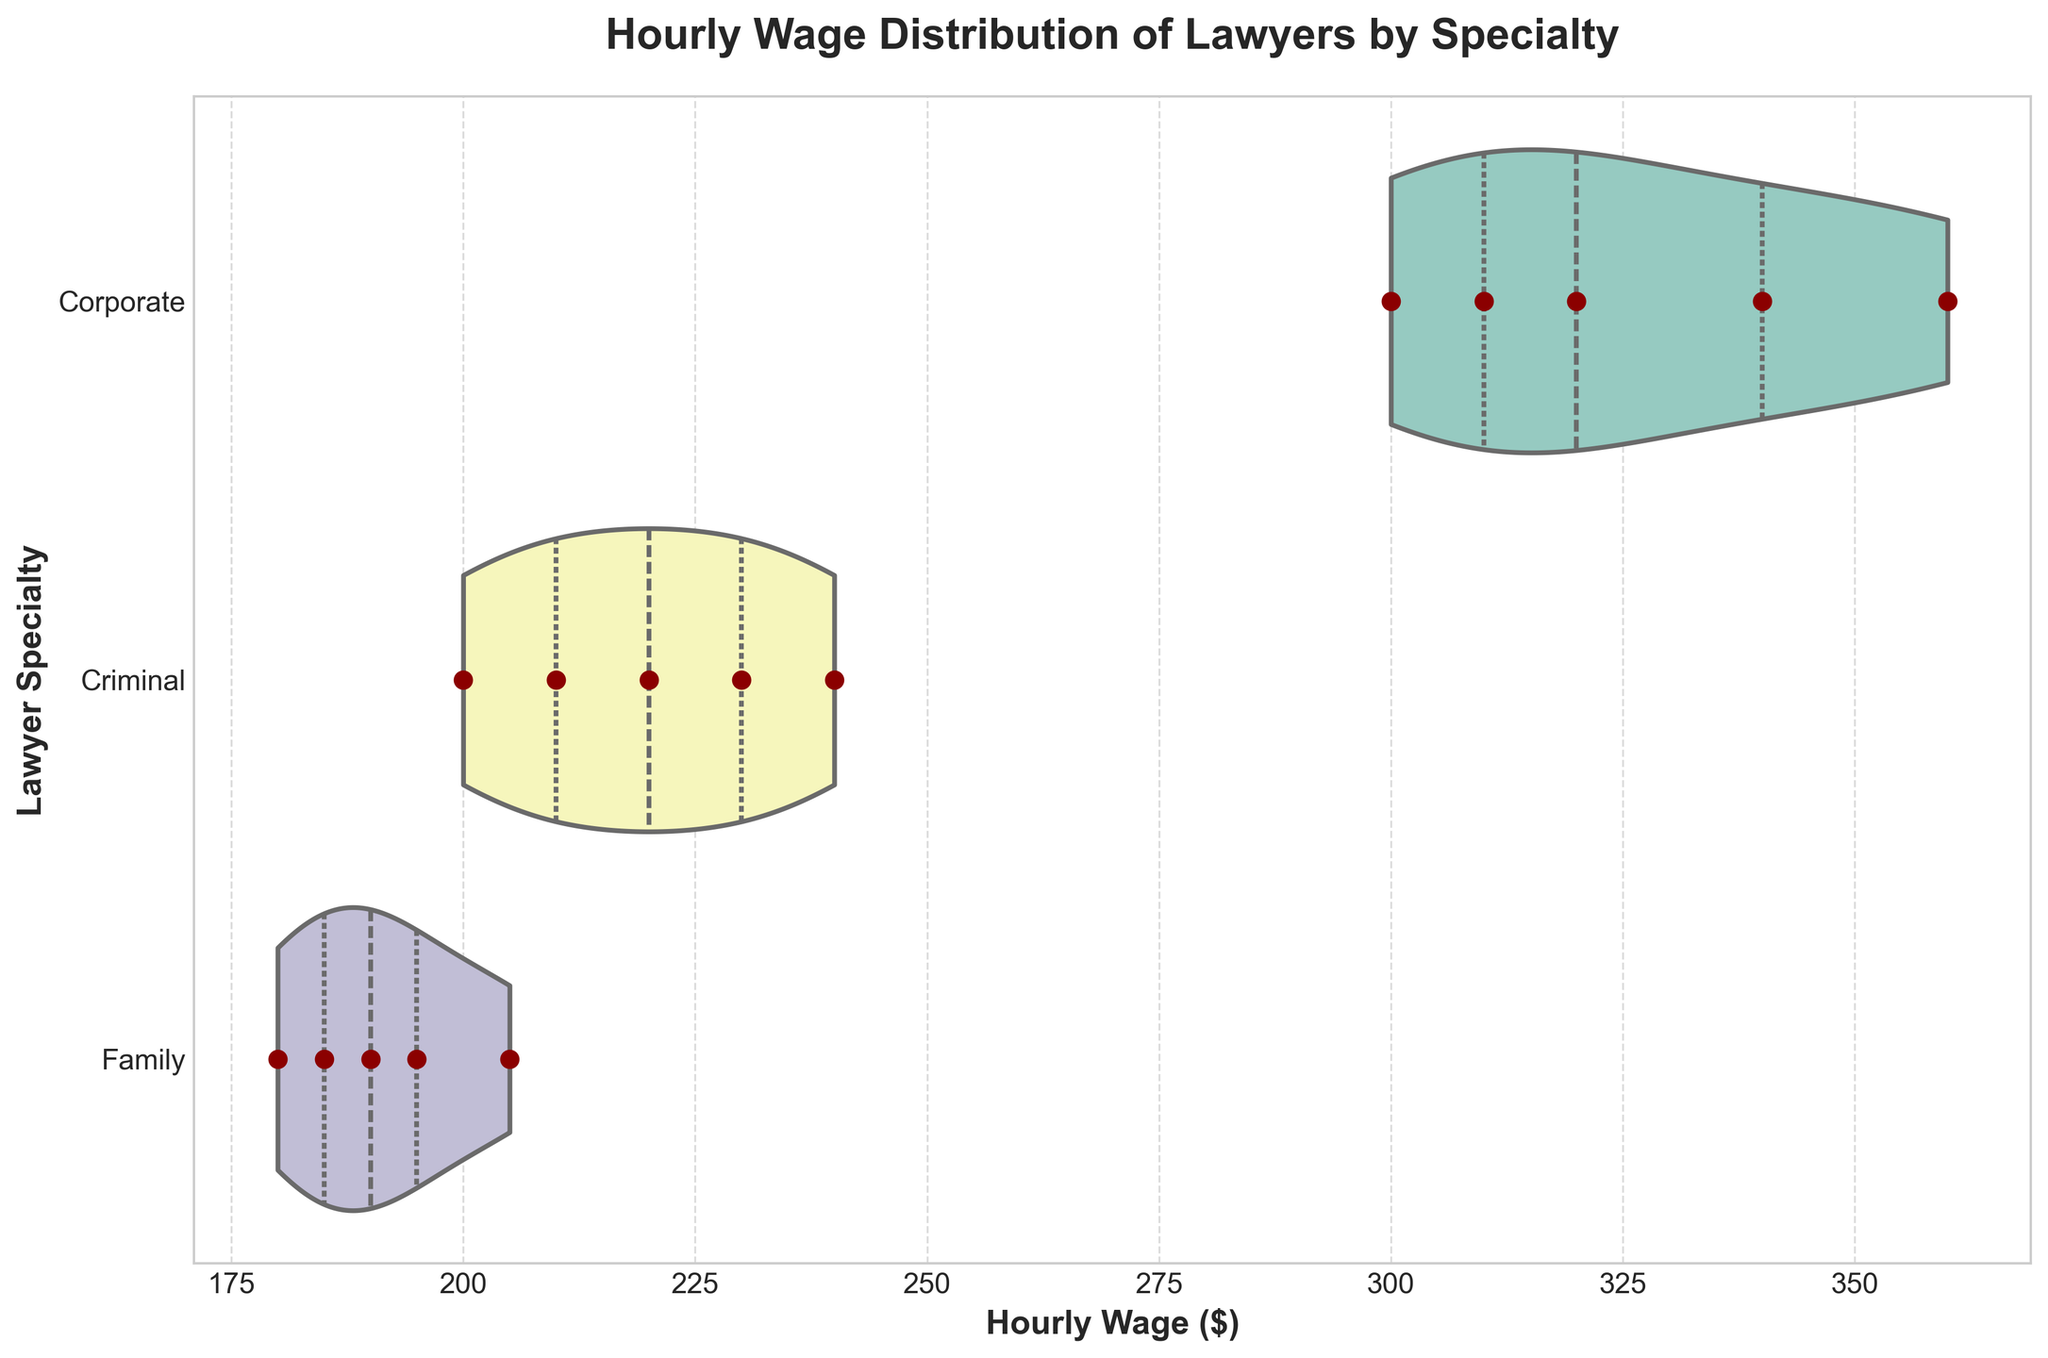What is the title of the figure? The title is displayed at the top of the figure in a larger, bold font.
Answer: Hourly Wage Distribution of Lawyers by Specialty What is the highest hourly wage for Corporate lawyers? The violin plot for Corporate lawyers shows that the highest data point along the x-axis (Hourly Wage) is 360.
Answer: 360 How many Family lawyers are represented in the figure? Each individual data point for Family lawyers is shown with scatter points along the Family specialty's line. There are 5 scatter points.
Answer: 5 What is the median hourly wage for Criminal lawyers? The median is depicted by the thick line inside the violin plot. For Criminal lawyers, this line intersects at 220.
Answer: 220 Which specialty has the widest distribution of hourly wages? By comparing the width of the violins from left to right, Corporate lawyers have the widest distribution of wages.
Answer: Corporate What is the difference between the maximum hourly wage for Corporate and Family lawyers? The maximum hourly wage for Corporate is 360 and for Family is 205. The difference is 360 - 205 = 155.
Answer: 155 Which lawyer specialty has the lowest hourly wage and what is it? The lowest hourly wage is marked at the minimum point of the plot. Family lawyers have the lowest at 180.
Answer: Family, 180 Is the range of hourly wages for Criminal lawyers greater than that of Family lawyers? The range for Criminal lawyers is the difference between 240 and 200 (240-200=40). For Family lawyers, it is 205 and 180 (205-180=25). Therefore, 40 > 25.
Answer: Yes What is the interquartile range (IQR) for Family lawyers? The IQR is the range between the first and third quartiles. For Family lawyers, it looks like the IQR spans from approximately 185 to 195. So, 195 - 185 = 10.
Answer: 10 How does the median hourly wage for Corporate lawyers compare to that for Criminal and Family lawyers? The median for Corporate is 320, for Criminal is 220, and for Family is 190. Therefore, 320 > 220 > 190.
Answer: Corporate > Criminal > Family 